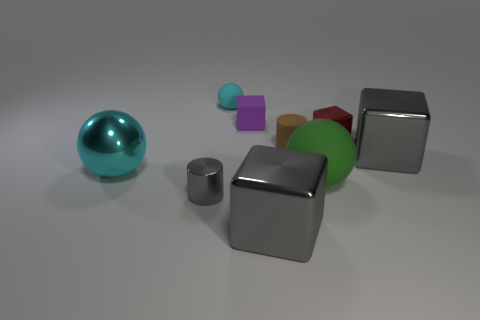There is a gray object that is to the left of the small ball; what is it made of?
Provide a short and direct response. Metal. What material is the large cube that is behind the gray cube on the left side of the small brown object made of?
Keep it short and to the point. Metal. The object that is the same color as the shiny sphere is what shape?
Offer a very short reply. Sphere. Is there a metallic object that has the same color as the shiny cylinder?
Provide a succinct answer. Yes. Do the large gray metallic object right of the red thing and the small metallic object in front of the big cyan thing have the same shape?
Give a very brief answer. No. How many things are blue shiny cubes or blocks in front of the red thing?
Your response must be concise. 2. What is the material of the ball that is both in front of the cyan rubber ball and right of the small gray metal thing?
Keep it short and to the point. Rubber. What color is the small cube that is made of the same material as the brown thing?
Ensure brevity in your answer.  Purple. How many things are either objects or green cylinders?
Keep it short and to the point. 9. Is the size of the brown cylinder the same as the ball that is on the left side of the small cyan rubber object?
Your answer should be compact. No. 